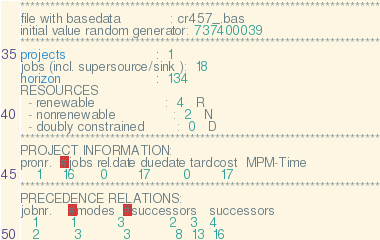Convert code to text. <code><loc_0><loc_0><loc_500><loc_500><_ObjectiveC_>************************************************************************
file with basedata            : cr457_.bas
initial value random generator: 737400039
************************************************************************
projects                      :  1
jobs (incl. supersource/sink ):  18
horizon                       :  134
RESOURCES
  - renewable                 :  4   R
  - nonrenewable              :  2   N
  - doubly constrained        :  0   D
************************************************************************
PROJECT INFORMATION:
pronr.  #jobs rel.date duedate tardcost  MPM-Time
    1     16      0       17        0       17
************************************************************************
PRECEDENCE RELATIONS:
jobnr.    #modes  #successors   successors
   1        1          3           2   3   4
   2        3          3           8  13  16</code> 